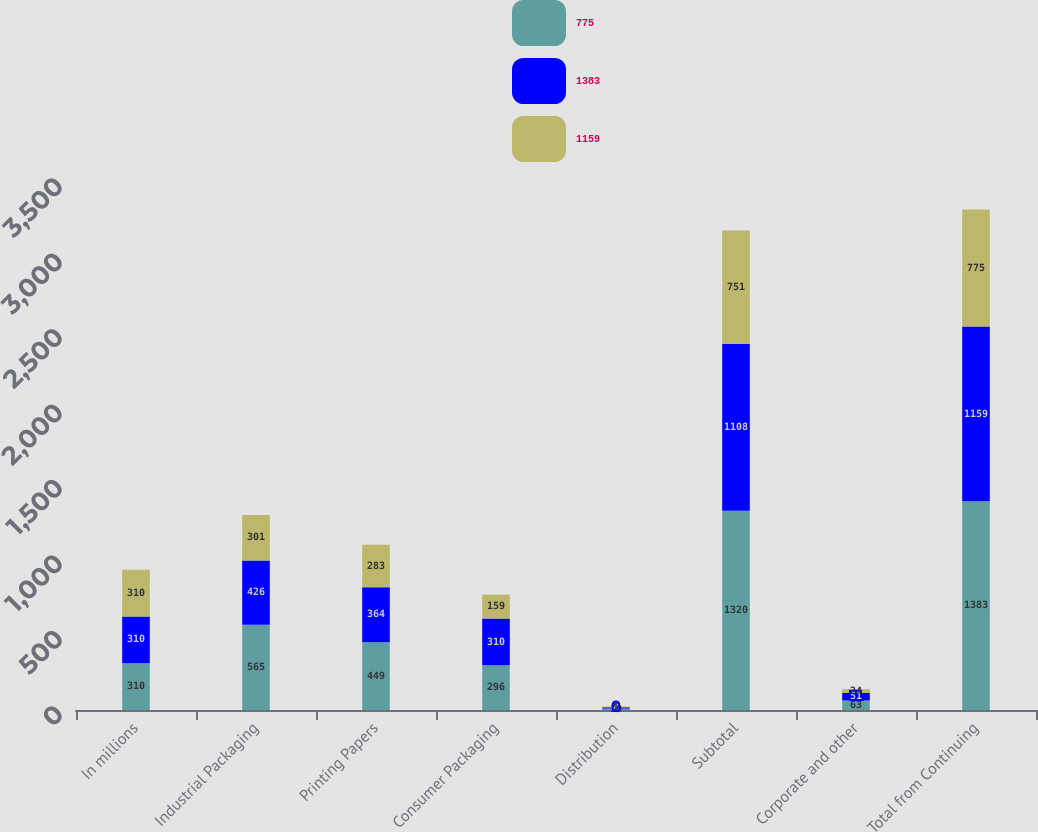Convert chart to OTSL. <chart><loc_0><loc_0><loc_500><loc_500><stacked_bar_chart><ecel><fcel>In millions<fcel>Industrial Packaging<fcel>Printing Papers<fcel>Consumer Packaging<fcel>Distribution<fcel>Subtotal<fcel>Corporate and other<fcel>Total from Continuing<nl><fcel>775<fcel>310<fcel>565<fcel>449<fcel>296<fcel>10<fcel>1320<fcel>63<fcel>1383<nl><fcel>1383<fcel>310<fcel>426<fcel>364<fcel>310<fcel>8<fcel>1108<fcel>51<fcel>1159<nl><fcel>1159<fcel>310<fcel>301<fcel>283<fcel>159<fcel>5<fcel>751<fcel>24<fcel>775<nl></chart> 